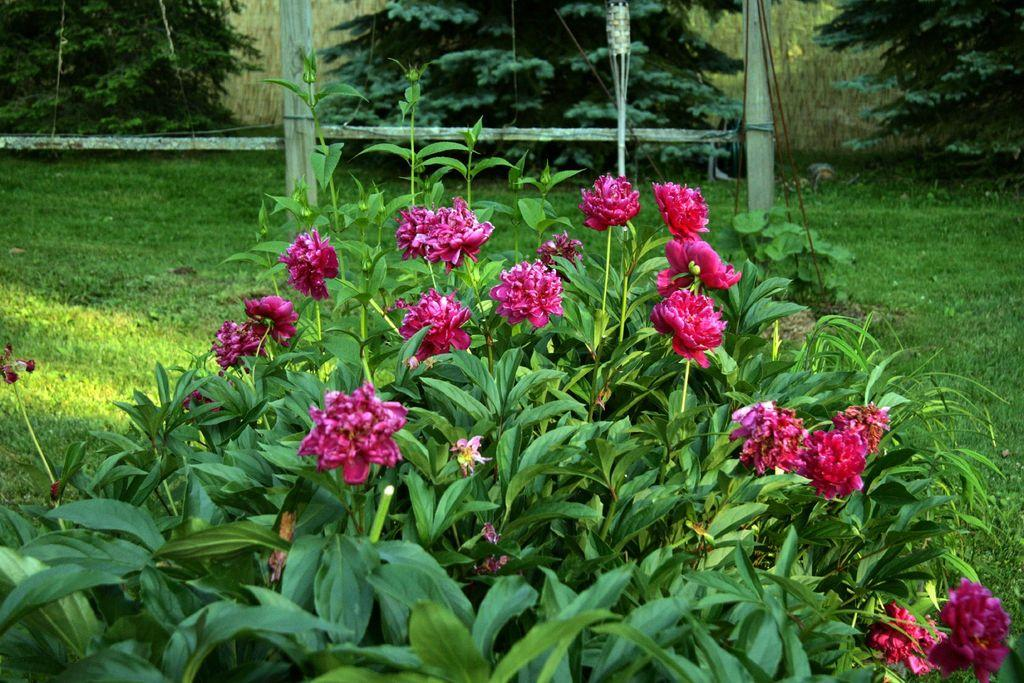What type of living organisms can be seen in the image? Plants and flowers can be seen in the image. What type of vegetation is visible at ground level in the image? There is grass visible in the image. What can be seen in the background of the image? There are trees in the background of the image. What type of behavior can be observed in the beggar in the image? There is no beggar present in the image. What is the top-most object in the image? The facts provided do not specify a top-most object in the image. 